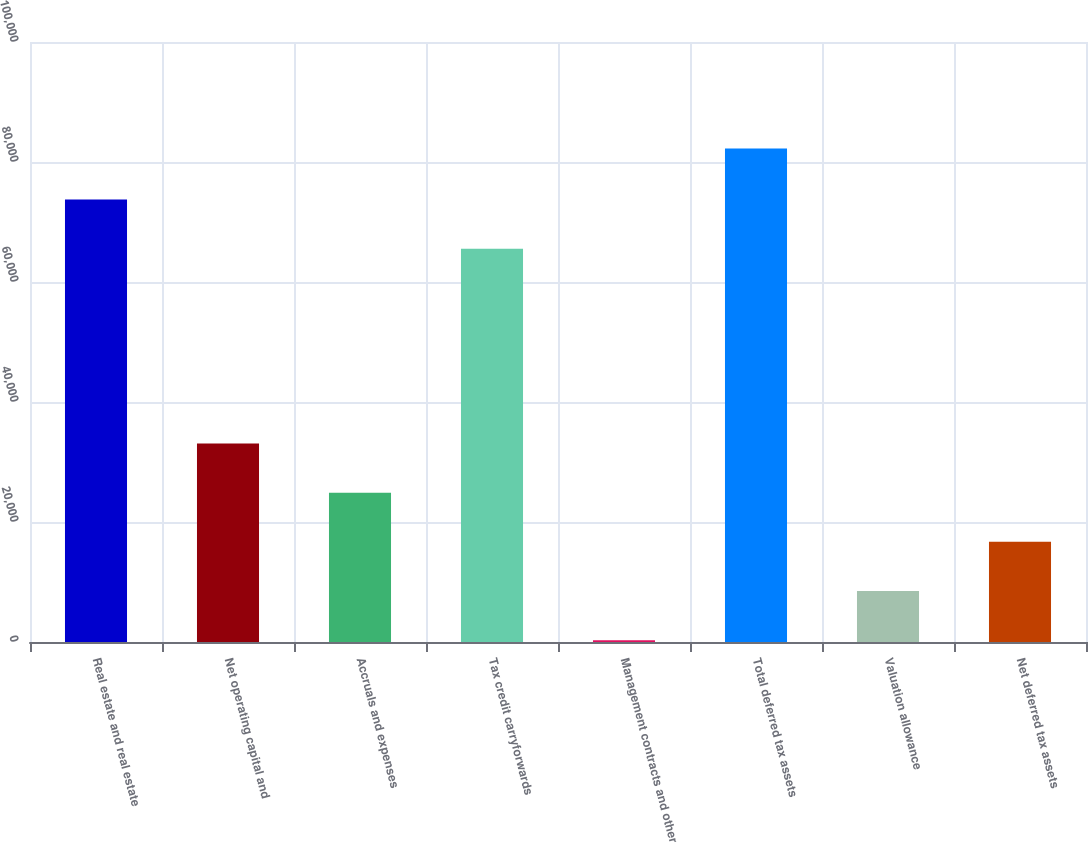Convert chart. <chart><loc_0><loc_0><loc_500><loc_500><bar_chart><fcel>Real estate and real estate<fcel>Net operating capital and<fcel>Accruals and expenses<fcel>Tax credit carryforwards<fcel>Management contracts and other<fcel>Total deferred tax assets<fcel>Valuation allowance<fcel>Net deferred tax assets<nl><fcel>73755.9<fcel>33087.6<fcel>24890.7<fcel>65559<fcel>300<fcel>82269<fcel>8496.9<fcel>16693.8<nl></chart> 